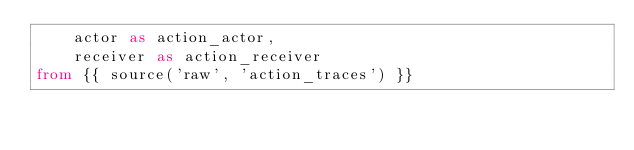Convert code to text. <code><loc_0><loc_0><loc_500><loc_500><_SQL_>    actor as action_actor,
    receiver as action_receiver
from {{ source('raw', 'action_traces') }}
</code> 